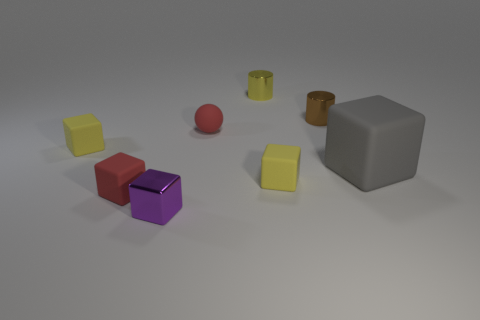Are there any big blue spheres that have the same material as the red sphere?
Provide a short and direct response. No. What is the size of the brown thing?
Offer a terse response. Small. There is a red matte thing behind the small red thing to the left of the purple metal cube; are there any metal objects that are in front of it?
Your response must be concise. Yes. What number of brown shiny cylinders are right of the metallic block?
Keep it short and to the point. 1. What number of small rubber objects have the same color as the ball?
Your answer should be very brief. 1. How many objects are either cubes right of the matte sphere or yellow objects that are behind the matte ball?
Give a very brief answer. 3. Is the number of tiny red rubber cubes greater than the number of small matte blocks?
Your answer should be very brief. No. There is a small metallic thing that is left of the tiny red rubber ball; what color is it?
Give a very brief answer. Purple. Do the large gray object and the tiny purple shiny object have the same shape?
Ensure brevity in your answer.  Yes. There is a rubber thing that is both right of the red rubber sphere and to the left of the big gray matte thing; what color is it?
Offer a terse response. Yellow. 